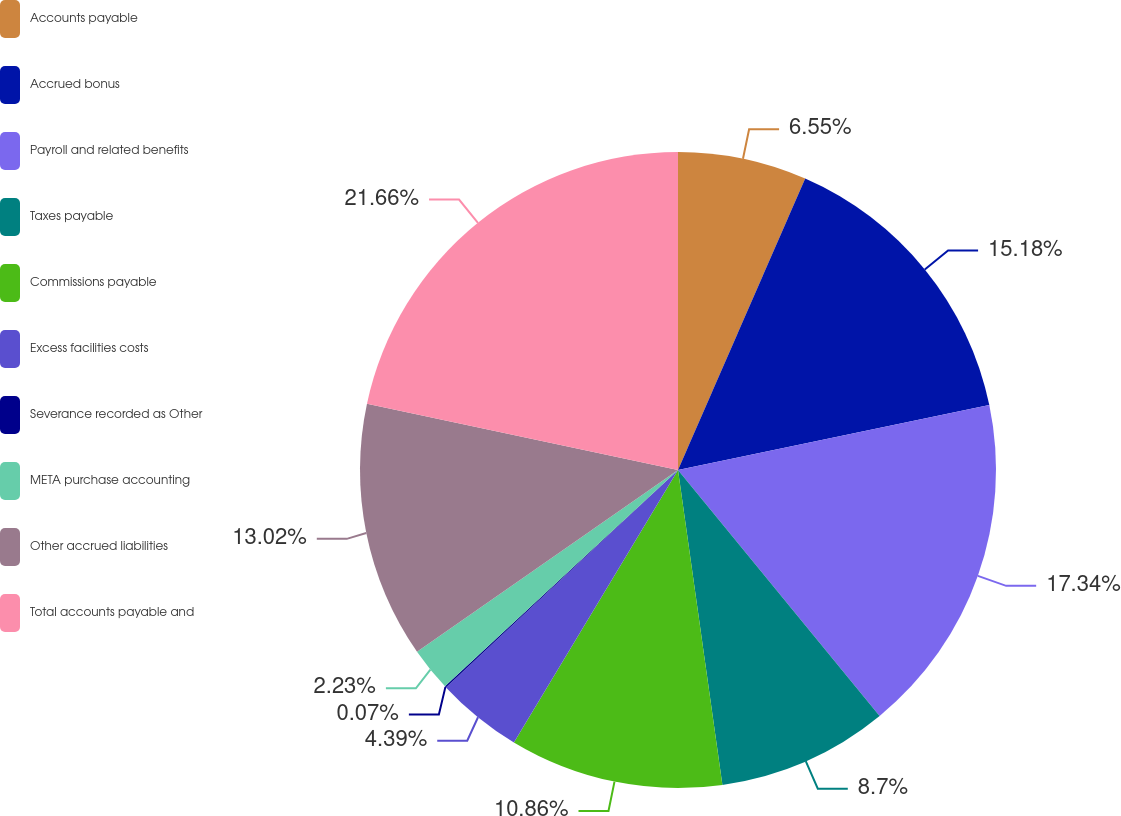Convert chart to OTSL. <chart><loc_0><loc_0><loc_500><loc_500><pie_chart><fcel>Accounts payable<fcel>Accrued bonus<fcel>Payroll and related benefits<fcel>Taxes payable<fcel>Commissions payable<fcel>Excess facilities costs<fcel>Severance recorded as Other<fcel>META purchase accounting<fcel>Other accrued liabilities<fcel>Total accounts payable and<nl><fcel>6.55%<fcel>15.18%<fcel>17.34%<fcel>8.7%<fcel>10.86%<fcel>4.39%<fcel>0.07%<fcel>2.23%<fcel>13.02%<fcel>21.66%<nl></chart> 